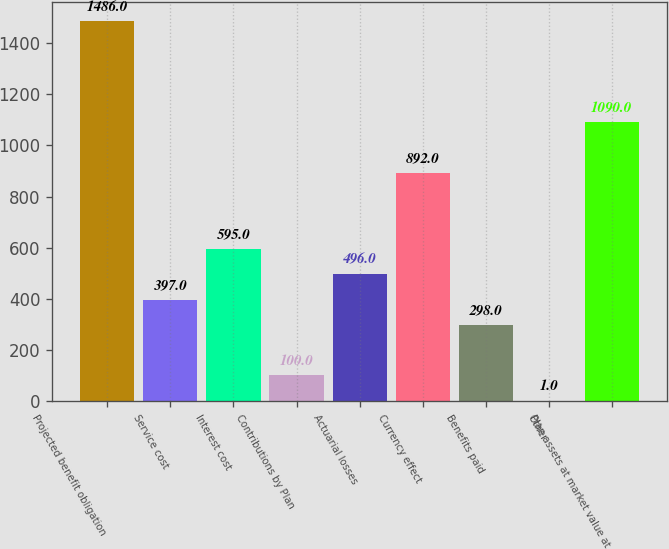Convert chart. <chart><loc_0><loc_0><loc_500><loc_500><bar_chart><fcel>Projected benefit obligation<fcel>Service cost<fcel>Interest cost<fcel>Contributions by Plan<fcel>Actuarial losses<fcel>Currency effect<fcel>Benefits paid<fcel>Other<fcel>Plan assets at market value at<nl><fcel>1486<fcel>397<fcel>595<fcel>100<fcel>496<fcel>892<fcel>298<fcel>1<fcel>1090<nl></chart> 